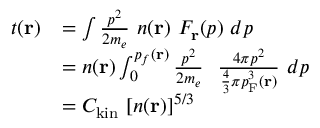Convert formula to latex. <formula><loc_0><loc_0><loc_500><loc_500>{ \begin{array} { r l } { t ( r ) } & { = \int { \frac { p ^ { 2 } } { 2 m _ { e } } } \ n ( r ) \ F _ { r } ( p ) \ d p } \\ & { = n ( r ) \int _ { 0 } ^ { p _ { f } ( r ) } { \frac { p ^ { 2 } } { 2 m _ { e } } } \ \ { \frac { 4 \pi p ^ { 2 } } { { \frac { 4 } { 3 } } \pi p _ { F } ^ { 3 } ( r ) } } \ d p } \\ & { = C _ { k i n } \ [ n ( r ) ] ^ { 5 / 3 } } \end{array} }</formula> 